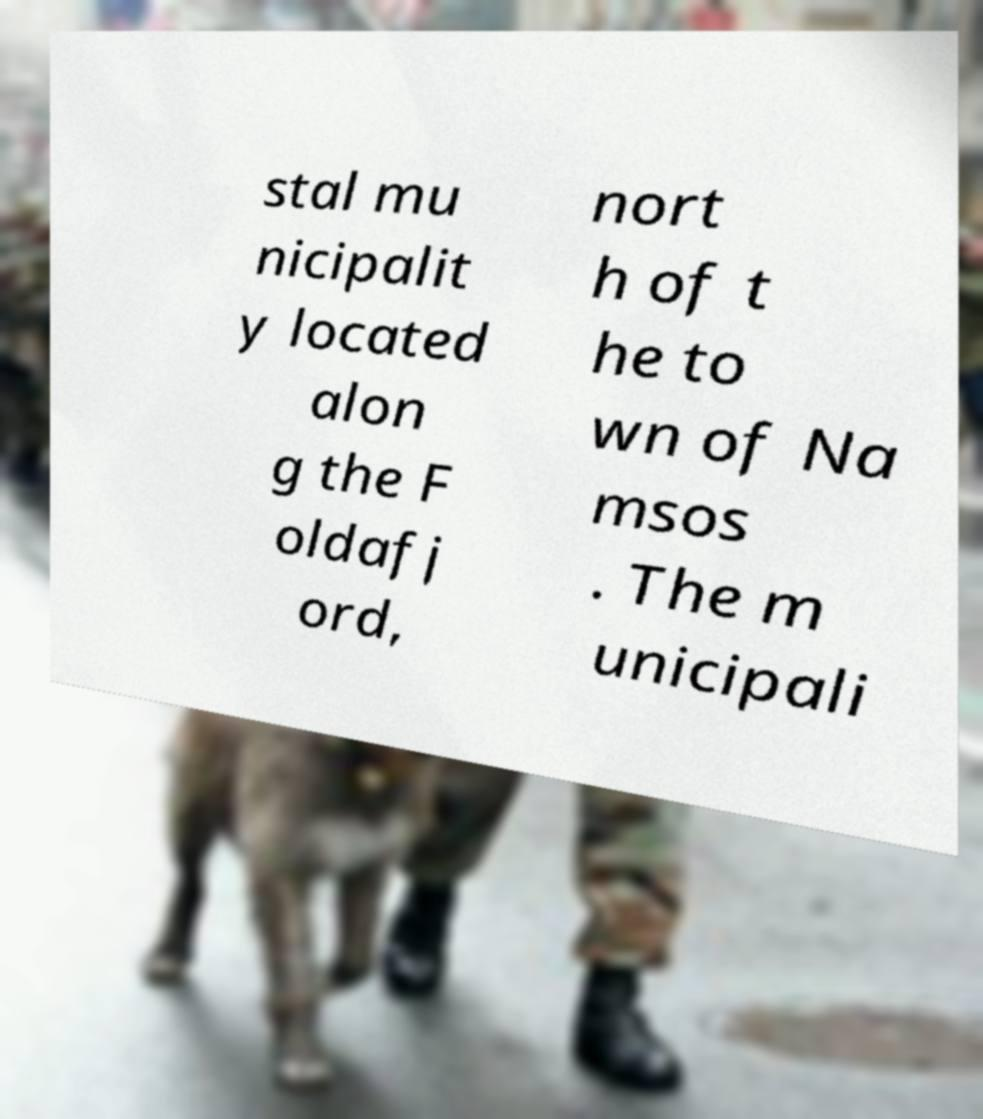Can you read and provide the text displayed in the image?This photo seems to have some interesting text. Can you extract and type it out for me? stal mu nicipalit y located alon g the F oldafj ord, nort h of t he to wn of Na msos . The m unicipali 